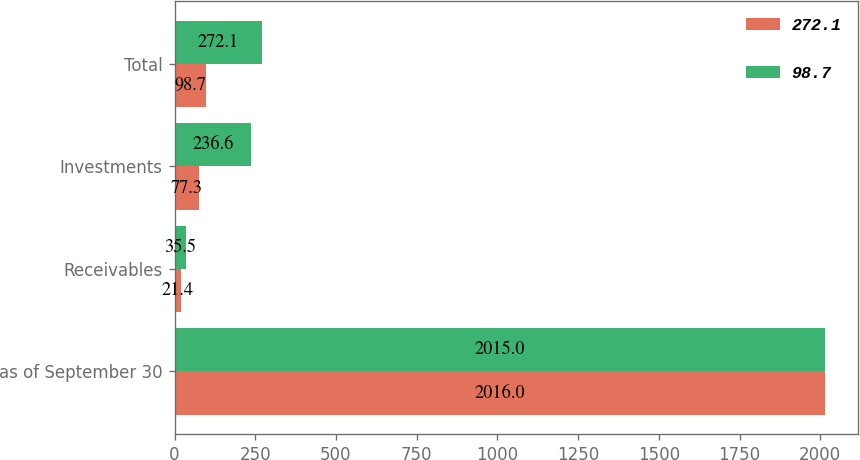Convert chart to OTSL. <chart><loc_0><loc_0><loc_500><loc_500><stacked_bar_chart><ecel><fcel>as of September 30<fcel>Receivables<fcel>Investments<fcel>Total<nl><fcel>272.1<fcel>2016<fcel>21.4<fcel>77.3<fcel>98.7<nl><fcel>98.7<fcel>2015<fcel>35.5<fcel>236.6<fcel>272.1<nl></chart> 